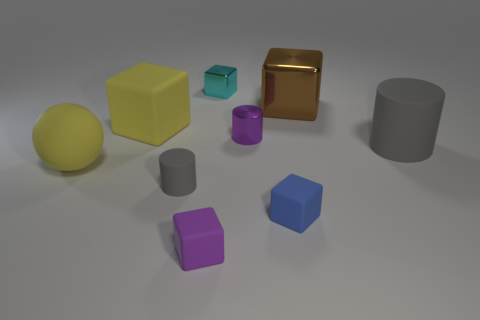Subtract 1 cubes. How many cubes are left? 4 Subtract all large matte cubes. How many cubes are left? 4 Subtract all brown blocks. How many blocks are left? 4 Subtract all green blocks. Subtract all gray cylinders. How many blocks are left? 5 Add 1 tiny matte cylinders. How many objects exist? 10 Subtract all cylinders. How many objects are left? 6 Subtract 1 cyan cubes. How many objects are left? 8 Subtract all blue matte balls. Subtract all small rubber things. How many objects are left? 6 Add 6 big yellow blocks. How many big yellow blocks are left? 7 Add 1 big yellow metallic spheres. How many big yellow metallic spheres exist? 1 